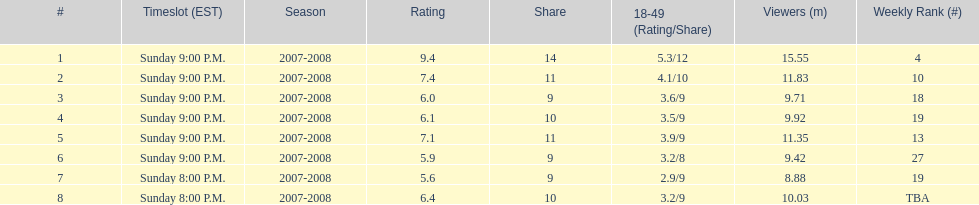Did the season finish at an earlier or later timeslot? Earlier. 